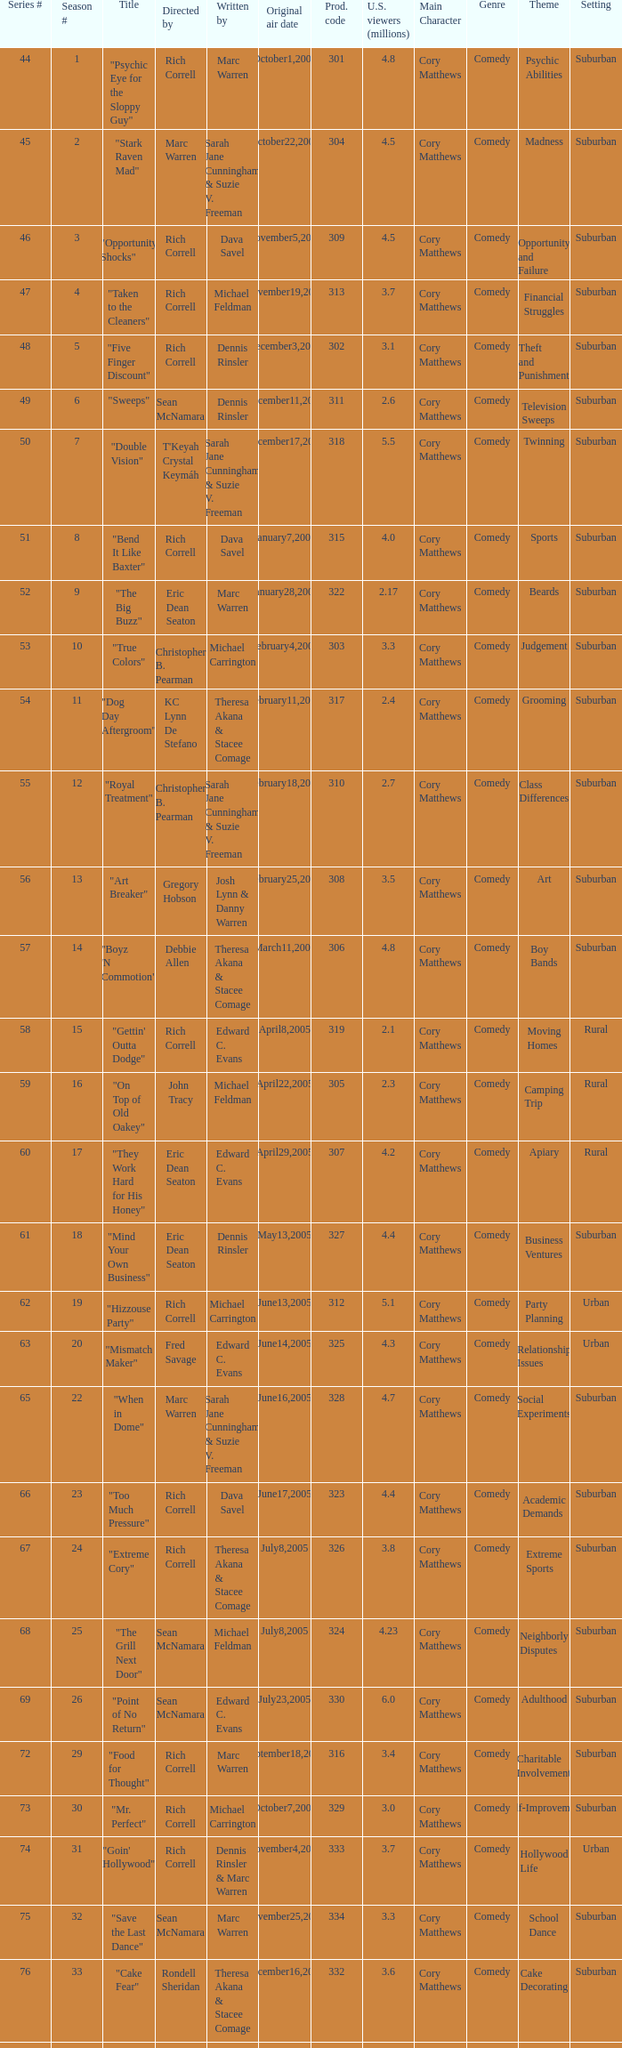What number episode in the season had a production code of 334? 32.0. 